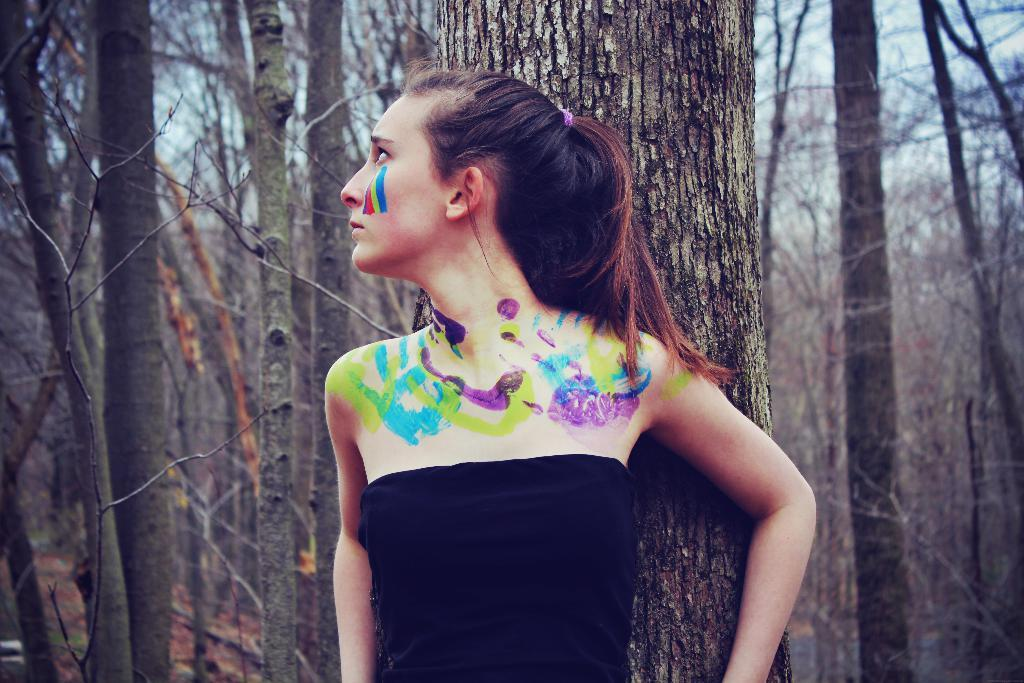What is the main subject of the image? There is a woman standing in the image. What is located behind the woman? There is a tree trunk behind the woman. What can be seen in the background of the image? There are trees and the sky visible in the background of the image. What type of ice can be seen melting on the woman's shoulder in the image? There is no ice present on the woman's shoulder or anywhere else in the image. Are there any waste materials visible in the image? There is no mention of waste materials in the image, and none are visible. 